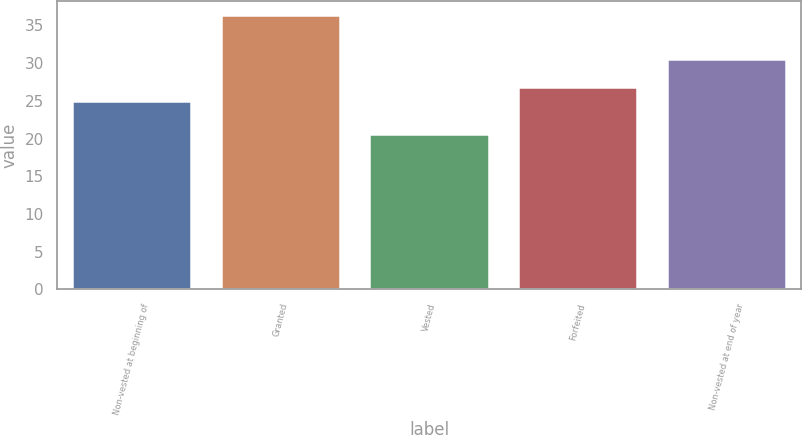<chart> <loc_0><loc_0><loc_500><loc_500><bar_chart><fcel>Non-vested at beginning of<fcel>Granted<fcel>Vested<fcel>Forfeited<fcel>Non-vested at end of year<nl><fcel>24.95<fcel>36.45<fcel>20.63<fcel>26.79<fcel>30.55<nl></chart> 